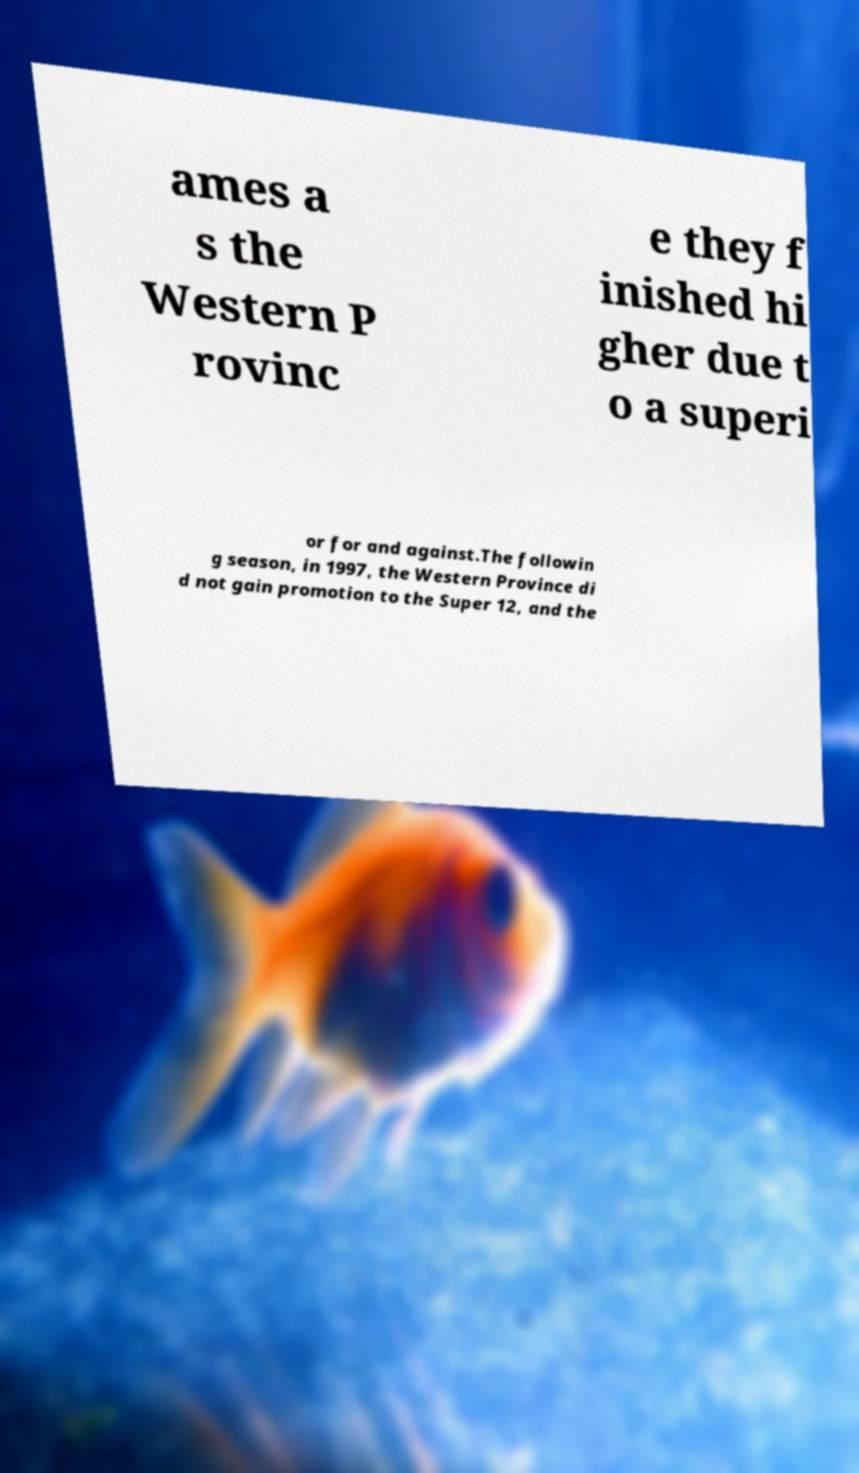I need the written content from this picture converted into text. Can you do that? ames a s the Western P rovinc e they f inished hi gher due t o a superi or for and against.The followin g season, in 1997, the Western Province di d not gain promotion to the Super 12, and the 